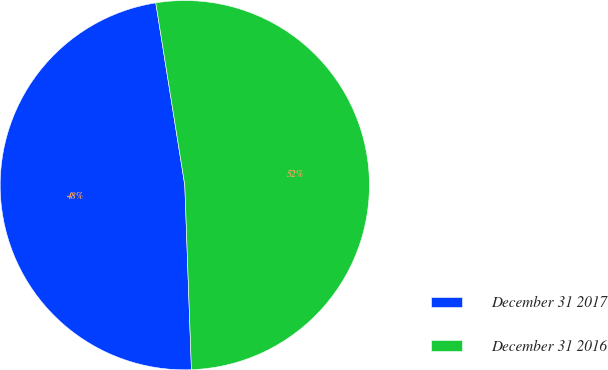Convert chart. <chart><loc_0><loc_0><loc_500><loc_500><pie_chart><fcel>December 31 2017<fcel>December 31 2016<nl><fcel>48.06%<fcel>51.94%<nl></chart> 